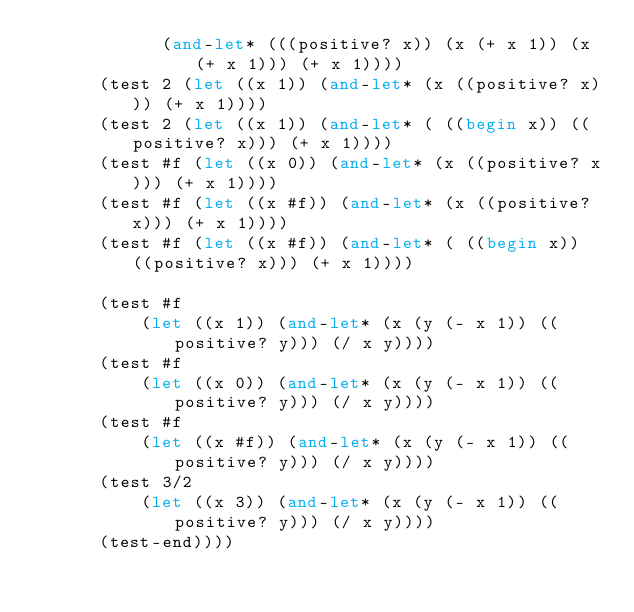Convert code to text. <code><loc_0><loc_0><loc_500><loc_500><_Scheme_>            (and-let* (((positive? x)) (x (+ x 1)) (x (+ x 1))) (+ x 1))))
      (test 2 (let ((x 1)) (and-let* (x ((positive? x))) (+ x 1))))
      (test 2 (let ((x 1)) (and-let* ( ((begin x)) ((positive? x))) (+ x 1))))
      (test #f (let ((x 0)) (and-let* (x ((positive? x))) (+ x 1))))
      (test #f (let ((x #f)) (and-let* (x ((positive? x))) (+ x 1))))
      (test #f (let ((x #f)) (and-let* ( ((begin x)) ((positive? x))) (+ x 1))))

      (test #f
          (let ((x 1)) (and-let* (x (y (- x 1)) ((positive? y))) (/ x y))))
      (test #f
          (let ((x 0)) (and-let* (x (y (- x 1)) ((positive? y))) (/ x y))))
      (test #f
          (let ((x #f)) (and-let* (x (y (- x 1)) ((positive? y))) (/ x y))))
      (test 3/2
          (let ((x 3)) (and-let* (x (y (- x 1)) ((positive? y))) (/ x y))))
      (test-end))))
</code> 